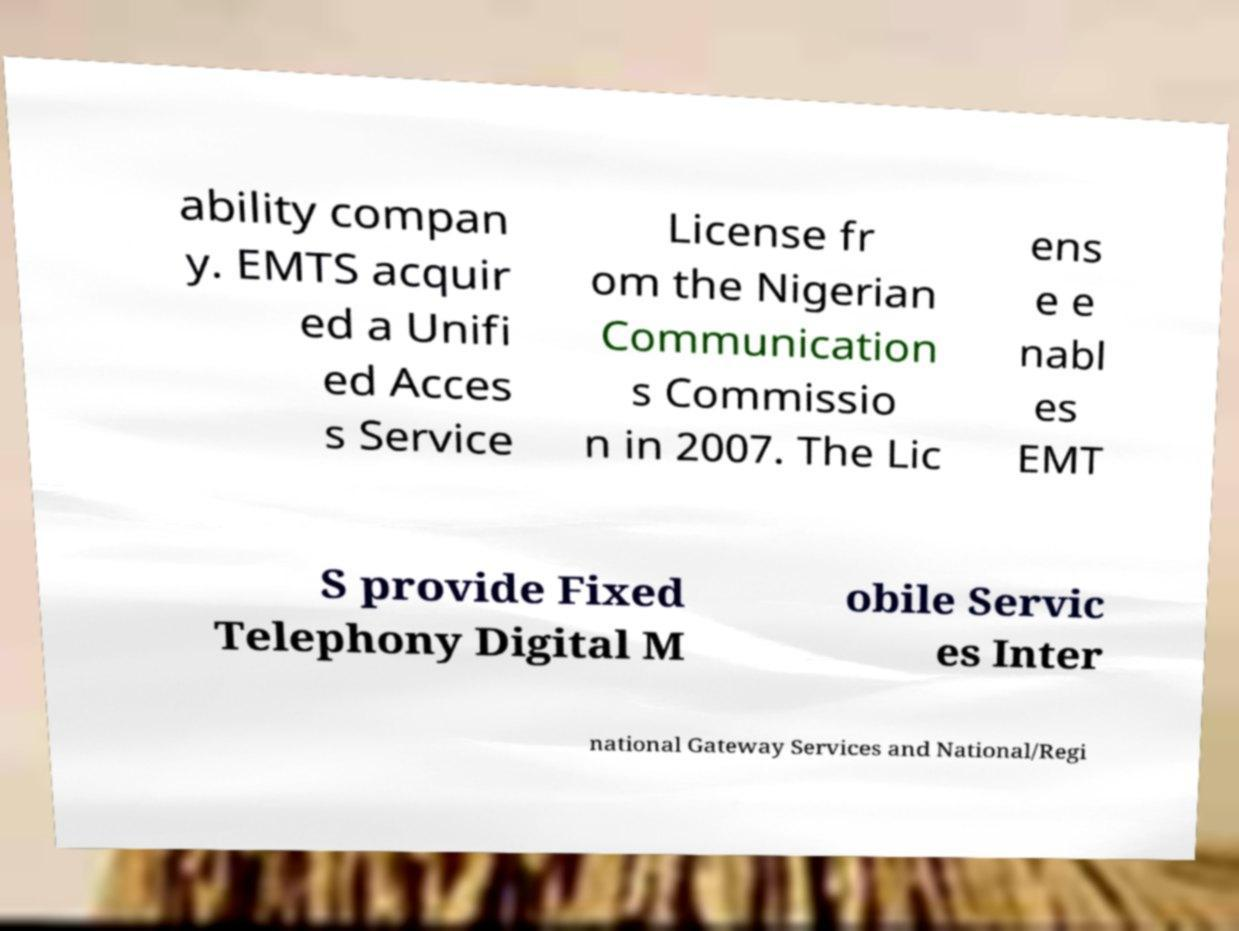Please read and relay the text visible in this image. What does it say? ability compan y. EMTS acquir ed a Unifi ed Acces s Service License fr om the Nigerian Communication s Commissio n in 2007. The Lic ens e e nabl es EMT S provide Fixed Telephony Digital M obile Servic es Inter national Gateway Services and National/Regi 